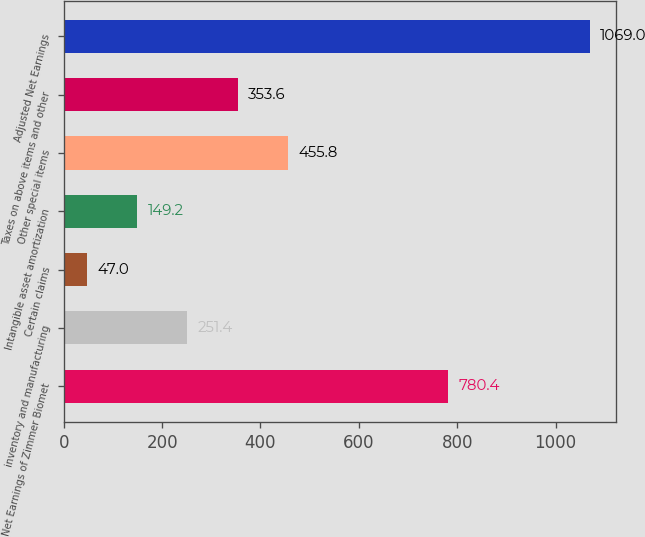Convert chart. <chart><loc_0><loc_0><loc_500><loc_500><bar_chart><fcel>Net Earnings of Zimmer Biomet<fcel>inventory and manufacturing<fcel>Certain claims<fcel>Intangible asset amortization<fcel>Other special items<fcel>Taxes on above items and other<fcel>Adjusted Net Earnings<nl><fcel>780.4<fcel>251.4<fcel>47<fcel>149.2<fcel>455.8<fcel>353.6<fcel>1069<nl></chart> 